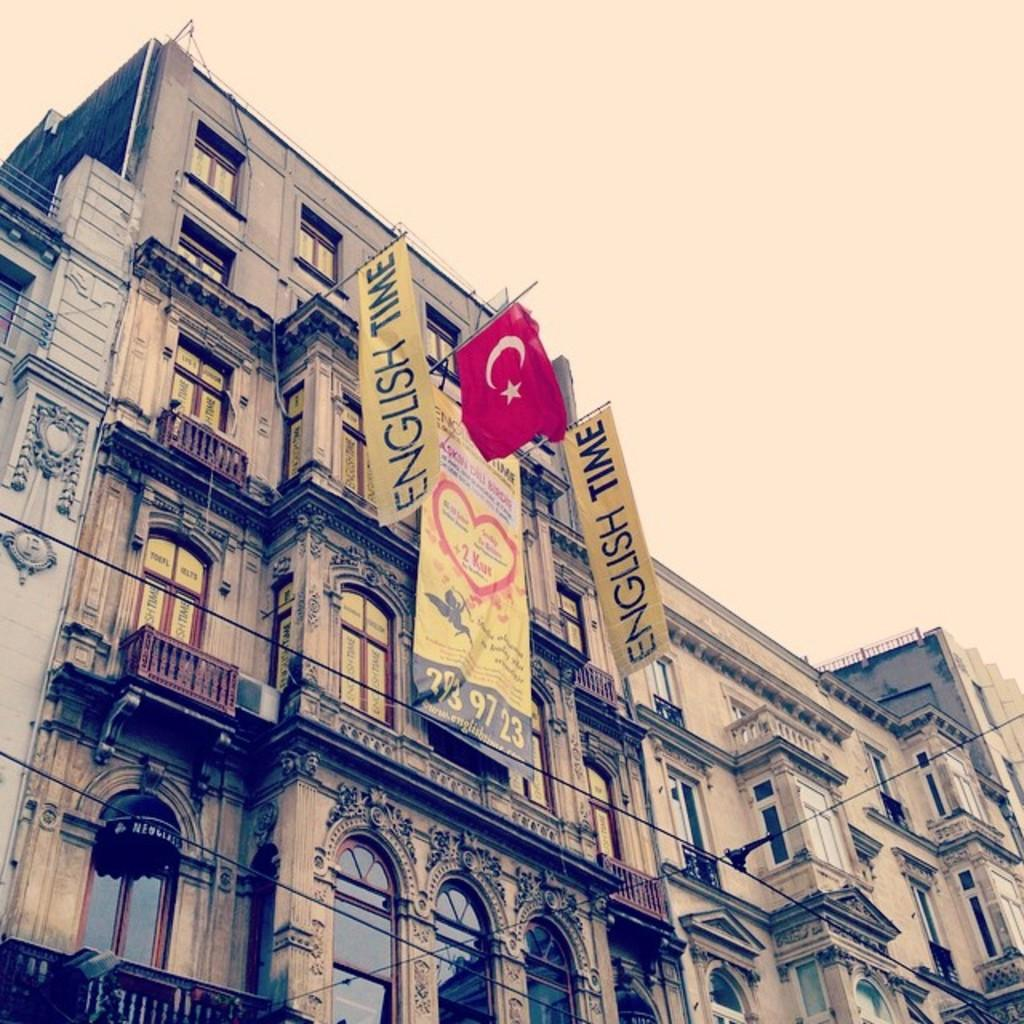What type of structure is present in the image? There is a building in the image. What features can be observed on the building? The building has windows and railings. What additional items are visible in the image? There are flags and a banner attached to the building. What can be seen in the background of the image? The sky is visible in the image. Can you see a snail crawling on the banner in the image? There is no snail present in the image; only the building, windows, railings, flags, and banner are visible. 